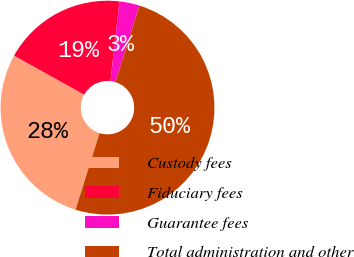Convert chart to OTSL. <chart><loc_0><loc_0><loc_500><loc_500><pie_chart><fcel>Custody fees<fcel>Fiduciary fees<fcel>Guarantee fees<fcel>Total administration and other<nl><fcel>28.26%<fcel>18.7%<fcel>3.04%<fcel>50.0%<nl></chart> 